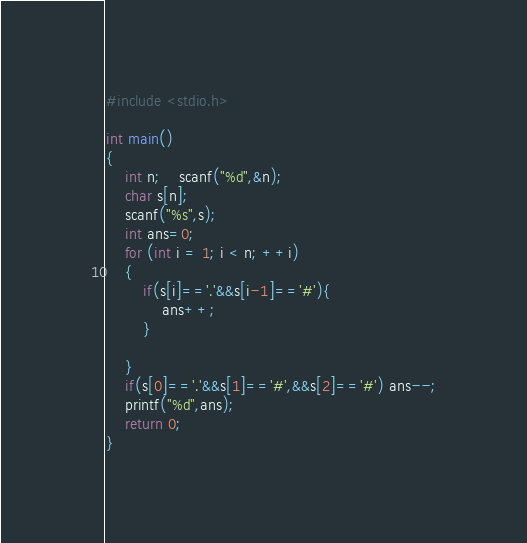Convert code to text. <code><loc_0><loc_0><loc_500><loc_500><_C_>#include <stdio.h>

int main()
{
	int n;	scanf("%d",&n);
	char s[n];
	scanf("%s",s);
	int ans=0;
	for (int i = 1; i < n; ++i)
	{
		if(s[i]=='.'&&s[i-1]=='#'){
			ans++;
		}
		
	}
	if(s[0]=='.'&&s[1]=='#',&&s[2]=='#') ans--;
	printf("%d",ans);
	return 0;
}
</code> 